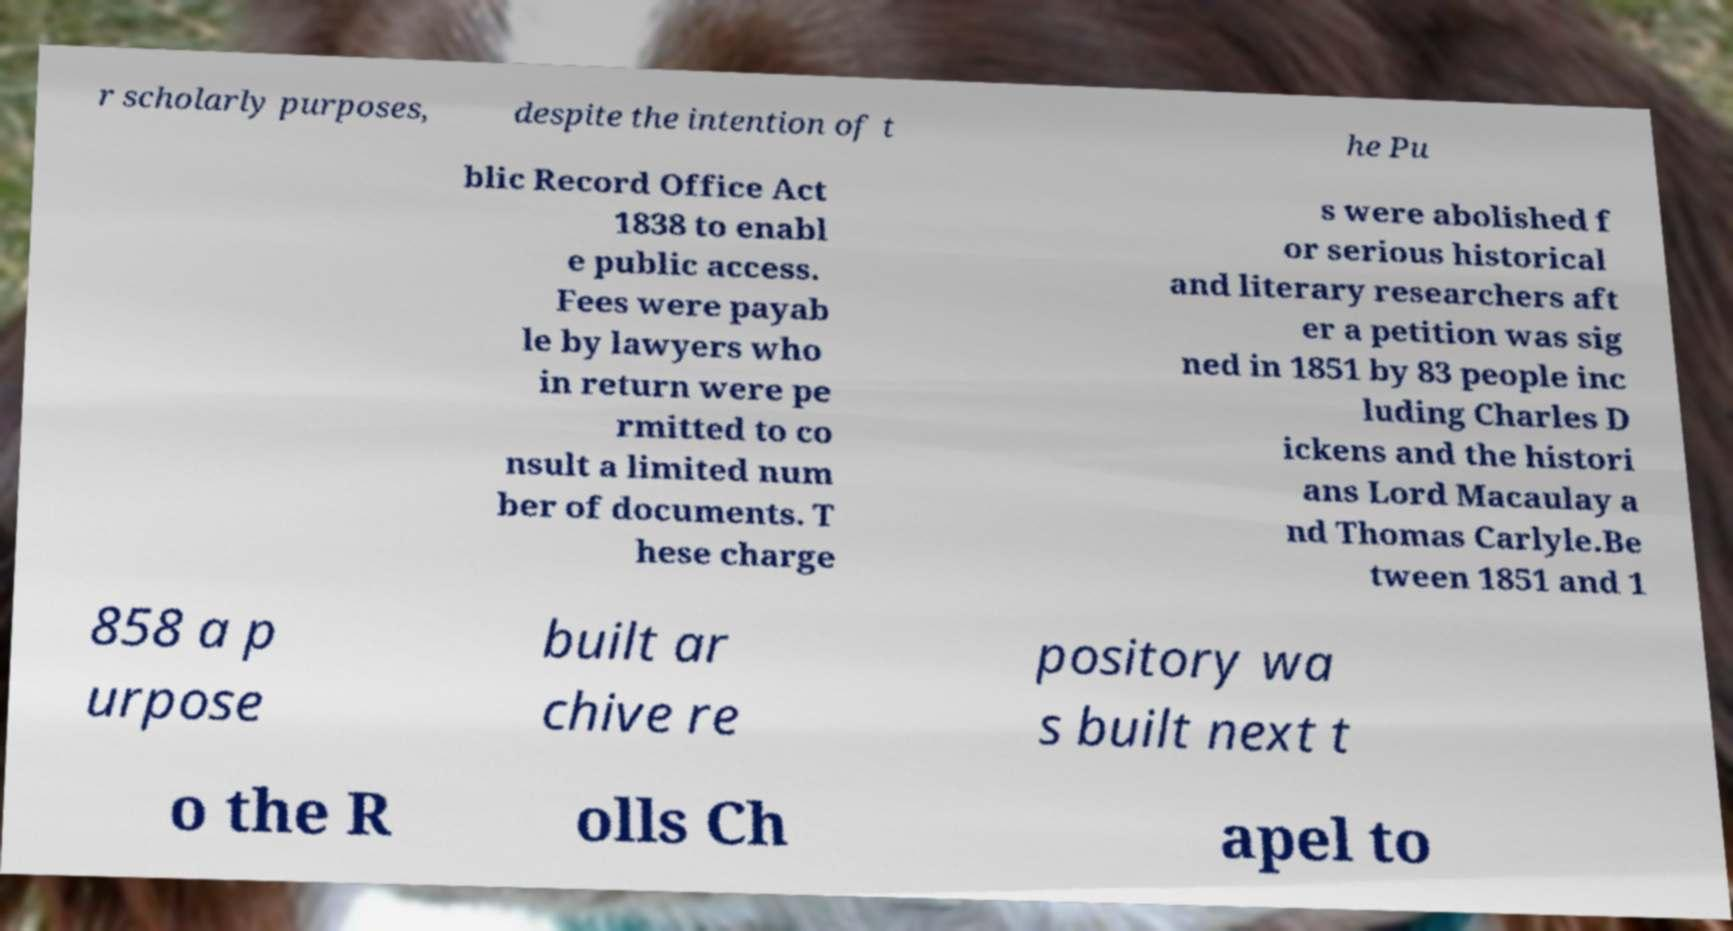For documentation purposes, I need the text within this image transcribed. Could you provide that? r scholarly purposes, despite the intention of t he Pu blic Record Office Act 1838 to enabl e public access. Fees were payab le by lawyers who in return were pe rmitted to co nsult a limited num ber of documents. T hese charge s were abolished f or serious historical and literary researchers aft er a petition was sig ned in 1851 by 83 people inc luding Charles D ickens and the histori ans Lord Macaulay a nd Thomas Carlyle.Be tween 1851 and 1 858 a p urpose built ar chive re pository wa s built next t o the R olls Ch apel to 